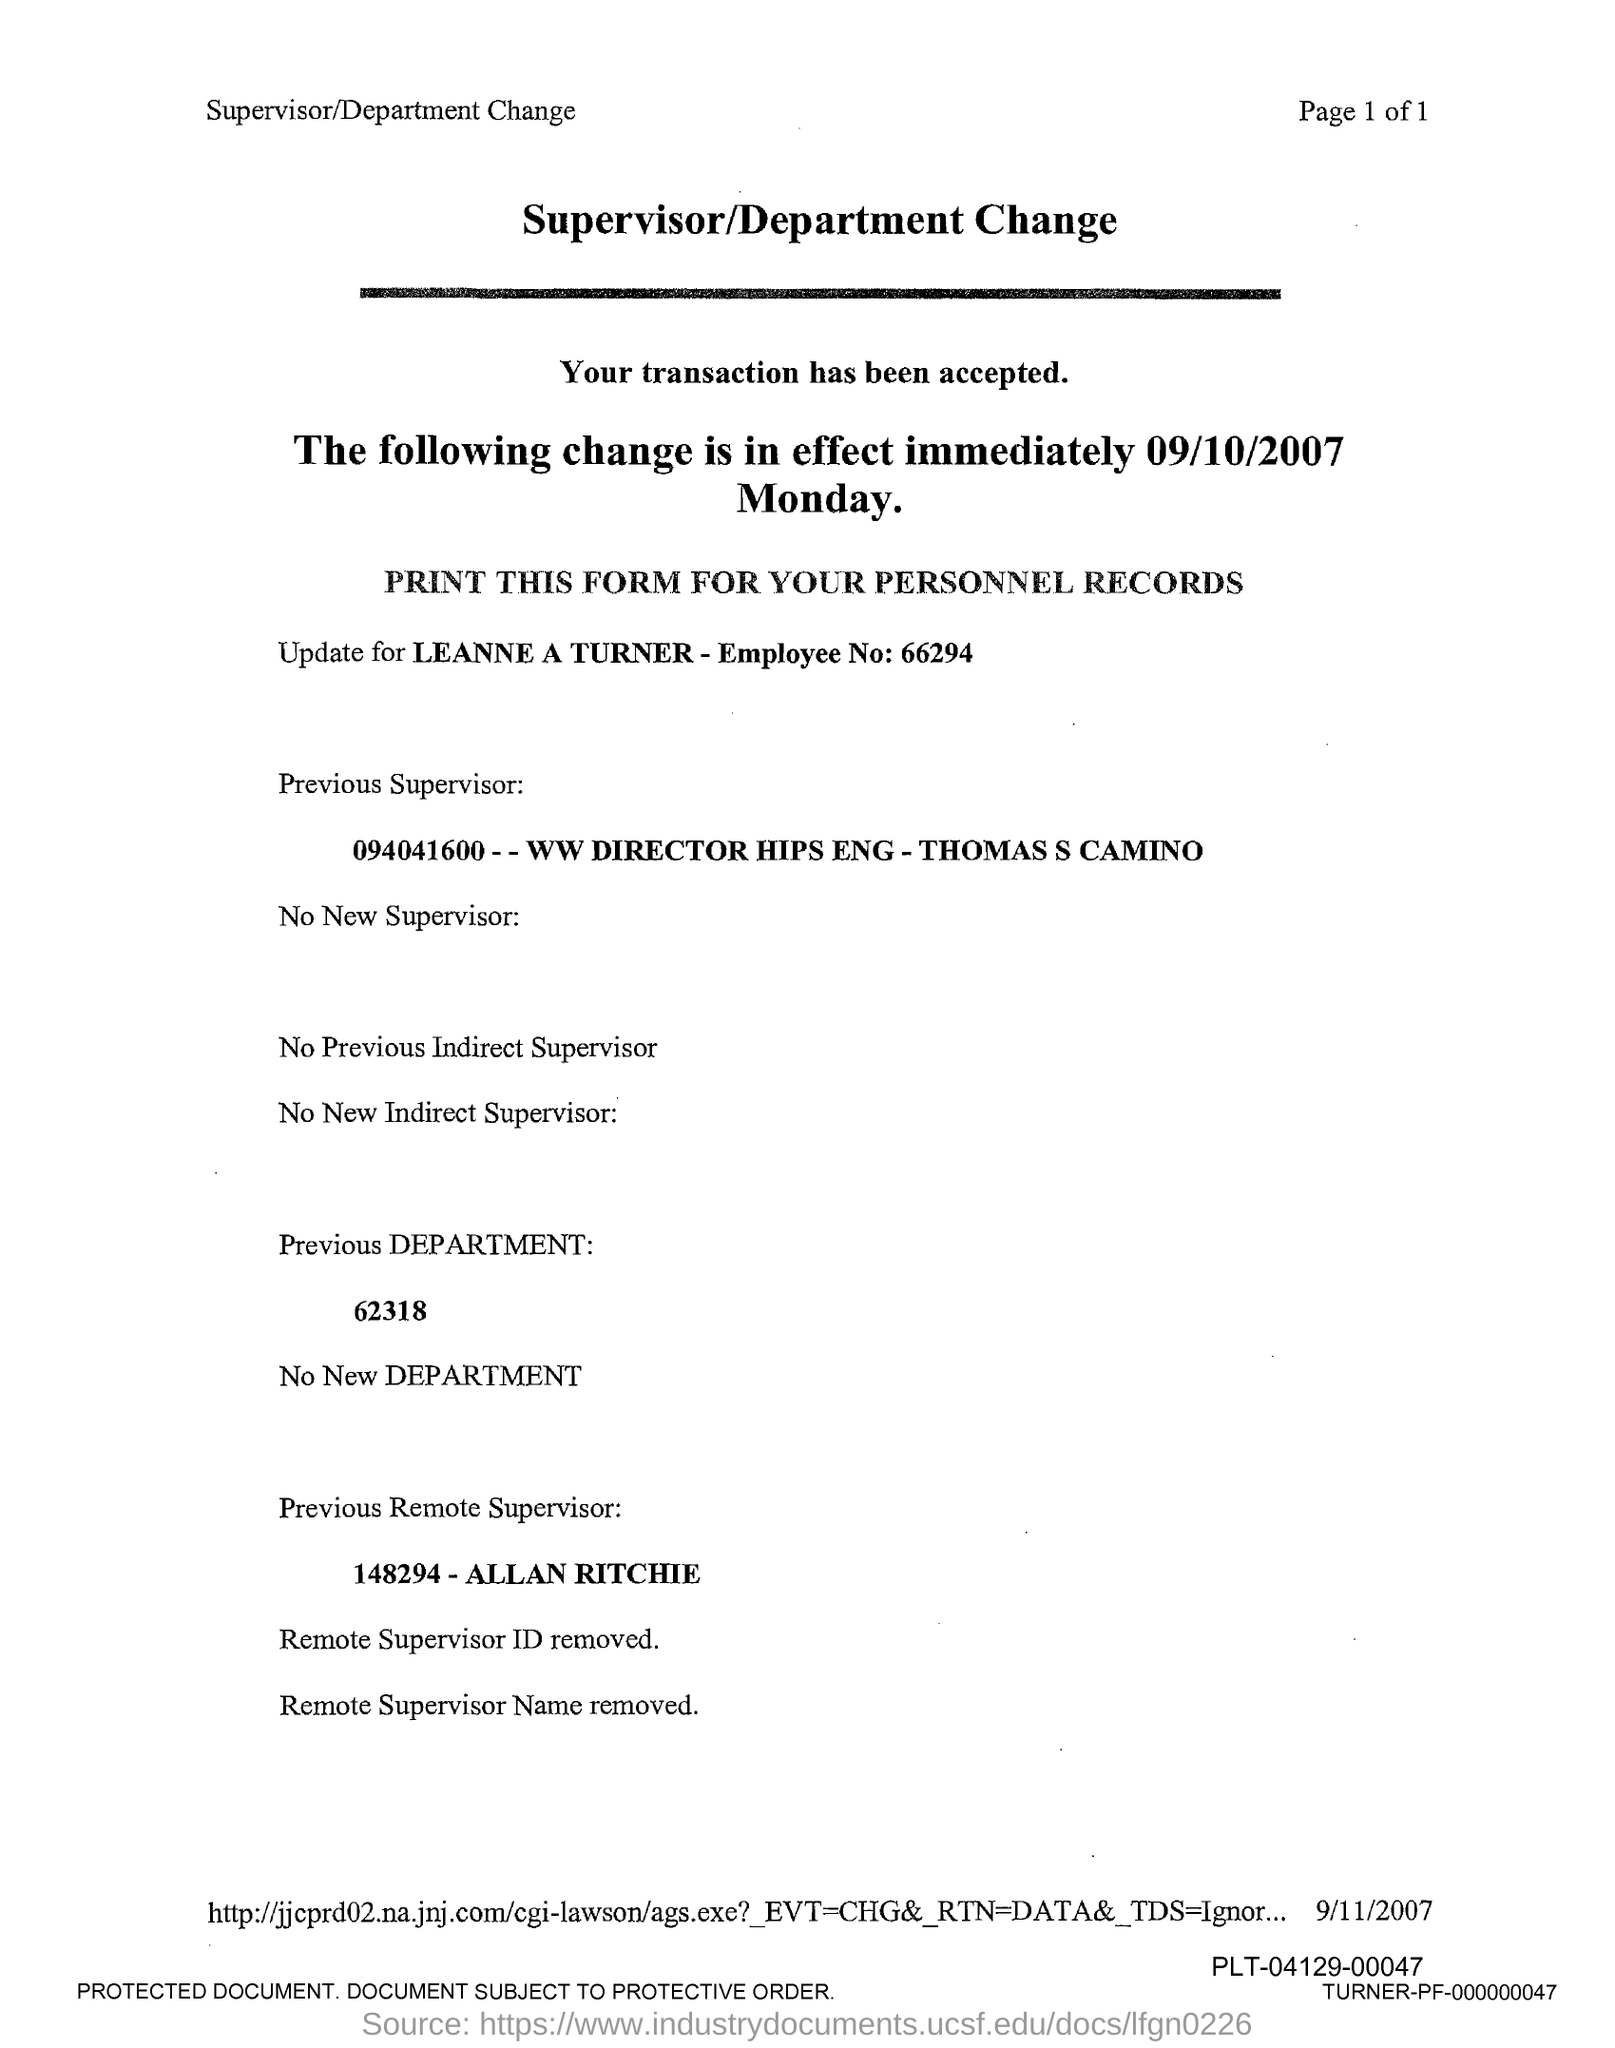What is the title?
Offer a very short reply. Supervisor/Department Change. What is the employee number of leanne a turner?
Your answer should be very brief. 66294. Who is the previous supervisor?
Offer a very short reply. Thomas S Camino. Who is the previous remote supervisor?
Provide a succinct answer. Allan Ritchie. 